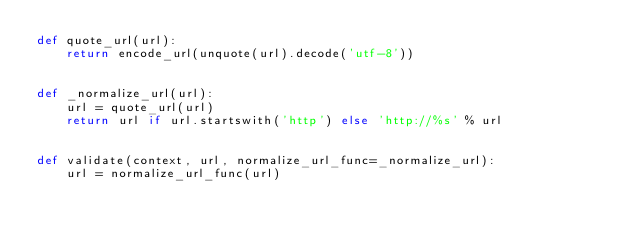<code> <loc_0><loc_0><loc_500><loc_500><_Python_>def quote_url(url):
    return encode_url(unquote(url).decode('utf-8'))


def _normalize_url(url):
    url = quote_url(url)
    return url if url.startswith('http') else 'http://%s' % url


def validate(context, url, normalize_url_func=_normalize_url):
    url = normalize_url_func(url)</code> 